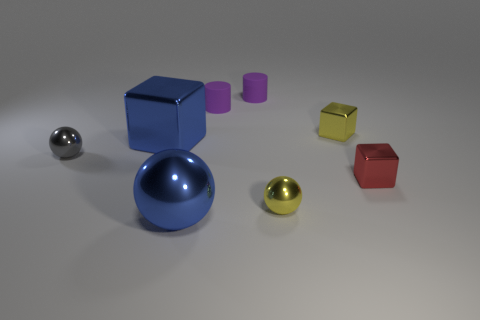Add 1 matte cylinders. How many objects exist? 9 Subtract all blocks. How many objects are left? 5 Subtract 2 cylinders. How many cylinders are left? 0 Subtract all red cylinders. Subtract all cyan balls. How many cylinders are left? 2 Subtract all blue balls. How many blue blocks are left? 1 Subtract all big green spheres. Subtract all balls. How many objects are left? 5 Add 4 tiny red blocks. How many tiny red blocks are left? 5 Add 1 small purple matte cylinders. How many small purple matte cylinders exist? 3 Subtract all small cubes. How many cubes are left? 1 Subtract 0 brown blocks. How many objects are left? 8 